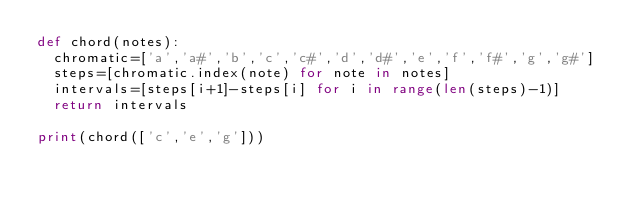<code> <loc_0><loc_0><loc_500><loc_500><_Python_>def chord(notes):
	chromatic=['a','a#','b','c','c#','d','d#','e','f','f#','g','g#']
	steps=[chromatic.index(note) for note in notes]
	intervals=[steps[i+1]-steps[i] for i in range(len(steps)-1)]
	return intervals

print(chord(['c','e','g']))</code> 